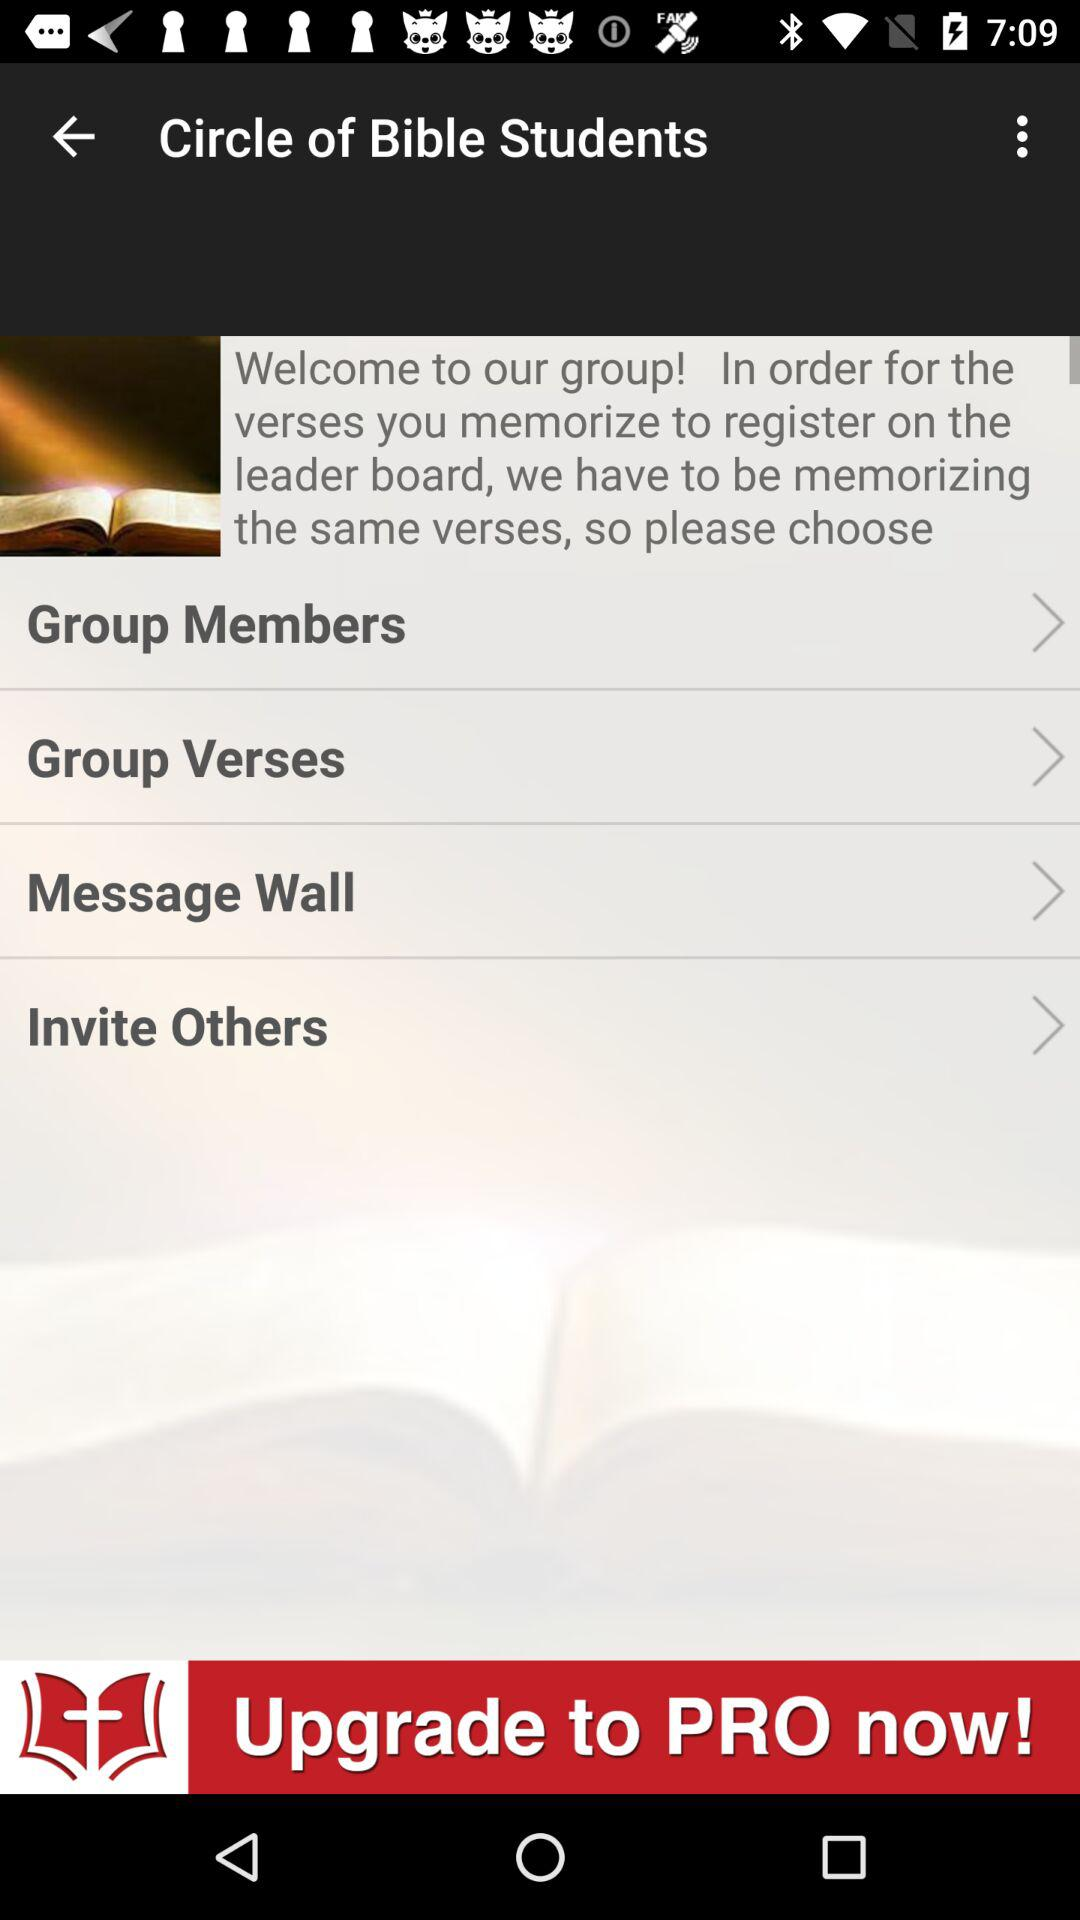How many items have an arrow forward?
Answer the question using a single word or phrase. 4 